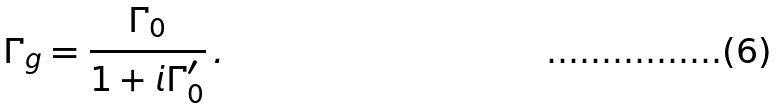<formula> <loc_0><loc_0><loc_500><loc_500>\Gamma _ { g } = \frac { \Gamma _ { 0 } } { 1 + i \Gamma _ { 0 } ^ { \prime } } \, .</formula> 